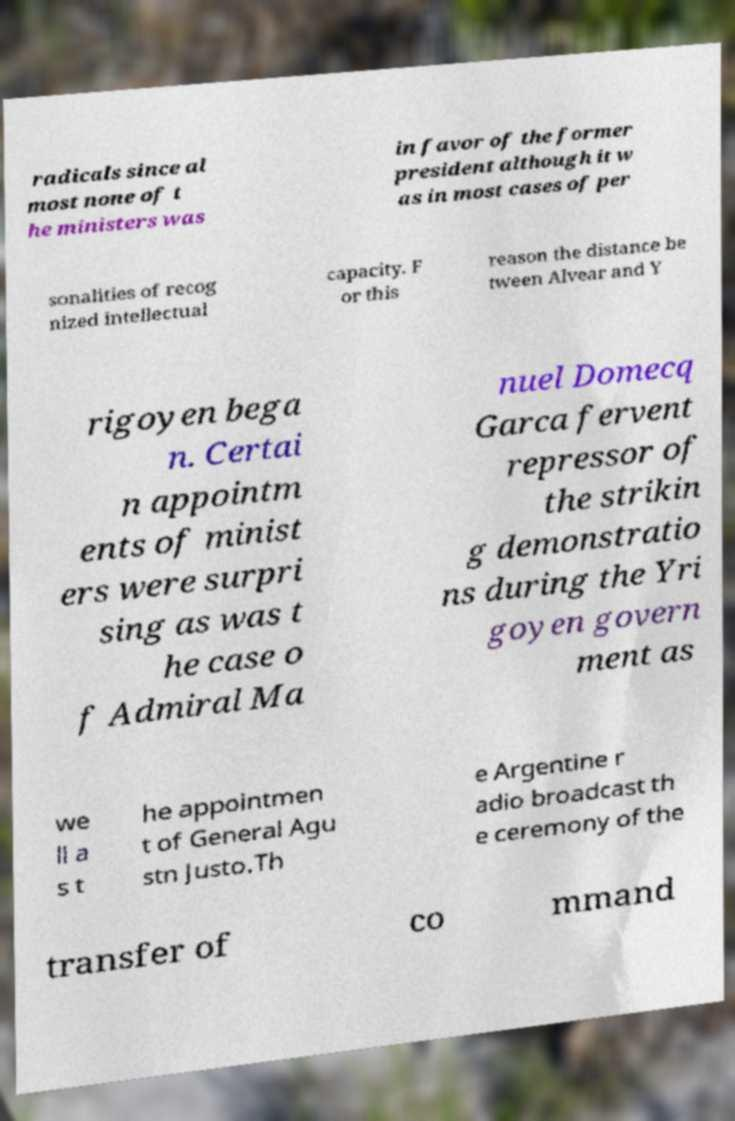Please read and relay the text visible in this image. What does it say? radicals since al most none of t he ministers was in favor of the former president although it w as in most cases of per sonalities of recog nized intellectual capacity. F or this reason the distance be tween Alvear and Y rigoyen bega n. Certai n appointm ents of minist ers were surpri sing as was t he case o f Admiral Ma nuel Domecq Garca fervent repressor of the strikin g demonstratio ns during the Yri goyen govern ment as we ll a s t he appointmen t of General Agu stn Justo.Th e Argentine r adio broadcast th e ceremony of the transfer of co mmand 